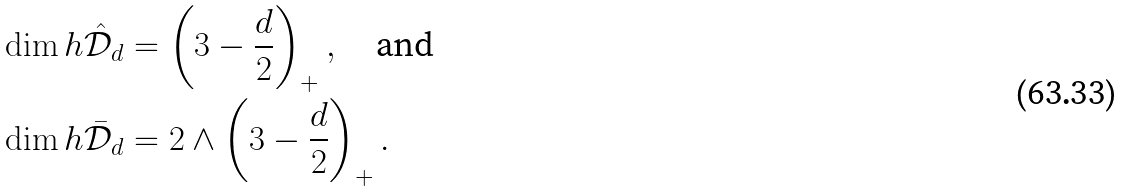Convert formula to latex. <formula><loc_0><loc_0><loc_500><loc_500>\dim h \hat { \mathcal { D } } _ { d } & = \left ( 3 - \frac { d } { 2 } \right ) _ { + } , \quad \text {and} \\ \dim h \bar { \mathcal { D } } _ { d } & = 2 \wedge \left ( 3 - \frac { d } { 2 } \right ) _ { + } .</formula> 